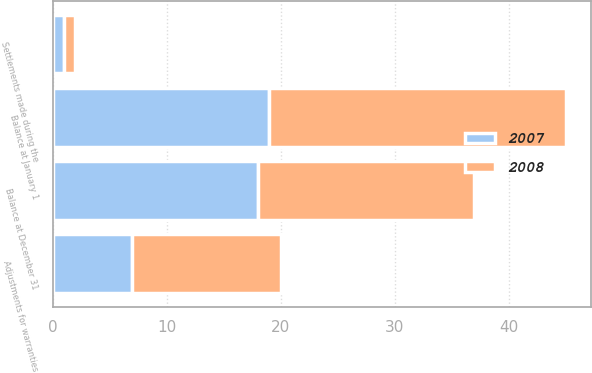Convert chart. <chart><loc_0><loc_0><loc_500><loc_500><stacked_bar_chart><ecel><fcel>Balance at January 1<fcel>Adjustments for warranties<fcel>Settlements made during the<fcel>Balance at December 31<nl><fcel>2007<fcel>19<fcel>7<fcel>1<fcel>18<nl><fcel>2008<fcel>26<fcel>13<fcel>1<fcel>19<nl></chart> 